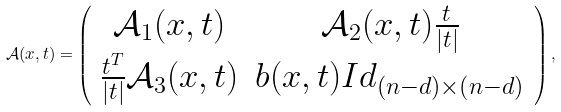Convert formula to latex. <formula><loc_0><loc_0><loc_500><loc_500>\mathcal { A } ( x , t ) = \left ( { \begin{array} { c c } \mathcal { A } _ { 1 } ( x , t ) & \mathcal { A } _ { 2 } ( x , t ) \frac { t } { | t | } \\ \frac { t ^ { T } } { | t | } \mathcal { A } _ { 3 } ( x , t ) & b ( x , t ) I d _ { ( n - d ) \times ( n - d ) } \\ \end{array} } \right ) ,</formula> 